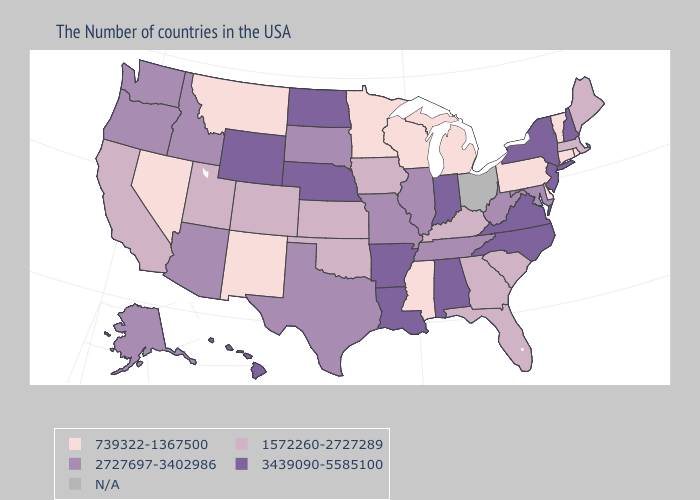Does the map have missing data?
Answer briefly. Yes. What is the highest value in the South ?
Give a very brief answer. 3439090-5585100. Name the states that have a value in the range N/A?
Quick response, please. Ohio. Name the states that have a value in the range 2727697-3402986?
Write a very short answer. Maryland, West Virginia, Tennessee, Illinois, Missouri, Texas, South Dakota, Arizona, Idaho, Washington, Oregon, Alaska. Among the states that border New Jersey , which have the highest value?
Give a very brief answer. New York. Does the map have missing data?
Answer briefly. Yes. What is the highest value in the West ?
Concise answer only. 3439090-5585100. Which states hav the highest value in the West?
Give a very brief answer. Wyoming, Hawaii. What is the value of Ohio?
Give a very brief answer. N/A. What is the value of Mississippi?
Write a very short answer. 739322-1367500. Name the states that have a value in the range 739322-1367500?
Short answer required. Rhode Island, Vermont, Connecticut, Delaware, Pennsylvania, Michigan, Wisconsin, Mississippi, Minnesota, New Mexico, Montana, Nevada. Does Nevada have the lowest value in the USA?
Concise answer only. Yes. How many symbols are there in the legend?
Quick response, please. 5. Does Nebraska have the highest value in the MidWest?
Keep it brief. Yes. 